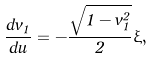Convert formula to latex. <formula><loc_0><loc_0><loc_500><loc_500>\frac { d v _ { 1 } } { d u } = - \frac { \sqrt { 1 - v _ { 1 } ^ { 2 } } } { 2 } \xi ,</formula> 